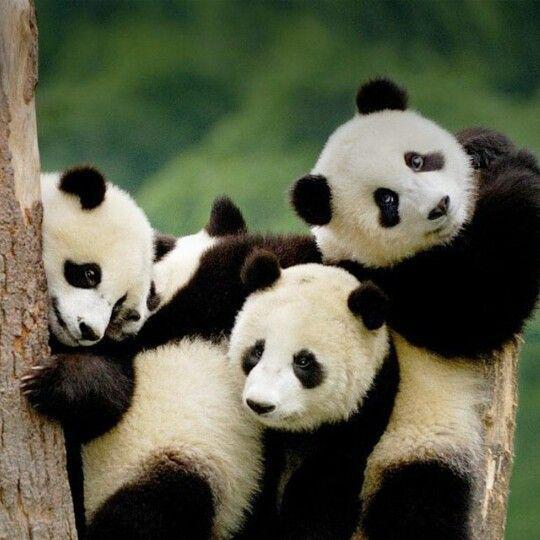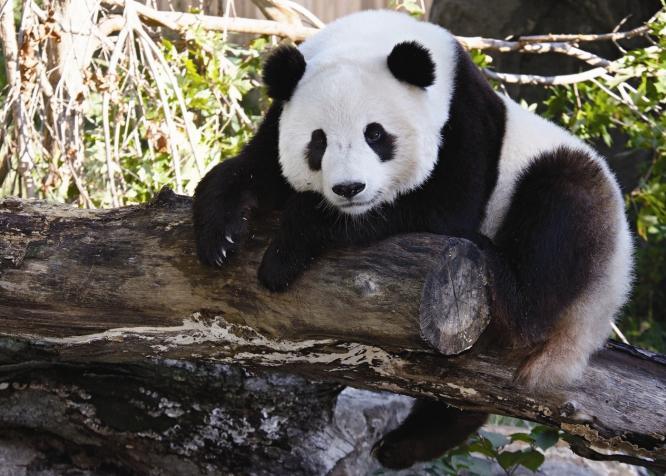The first image is the image on the left, the second image is the image on the right. Assess this claim about the two images: "There are exactly three pandas in the right image.". Correct or not? Answer yes or no. No. The first image is the image on the left, the second image is the image on the right. For the images displayed, is the sentence "There are four panda bears next to each other." factually correct? Answer yes or no. Yes. 